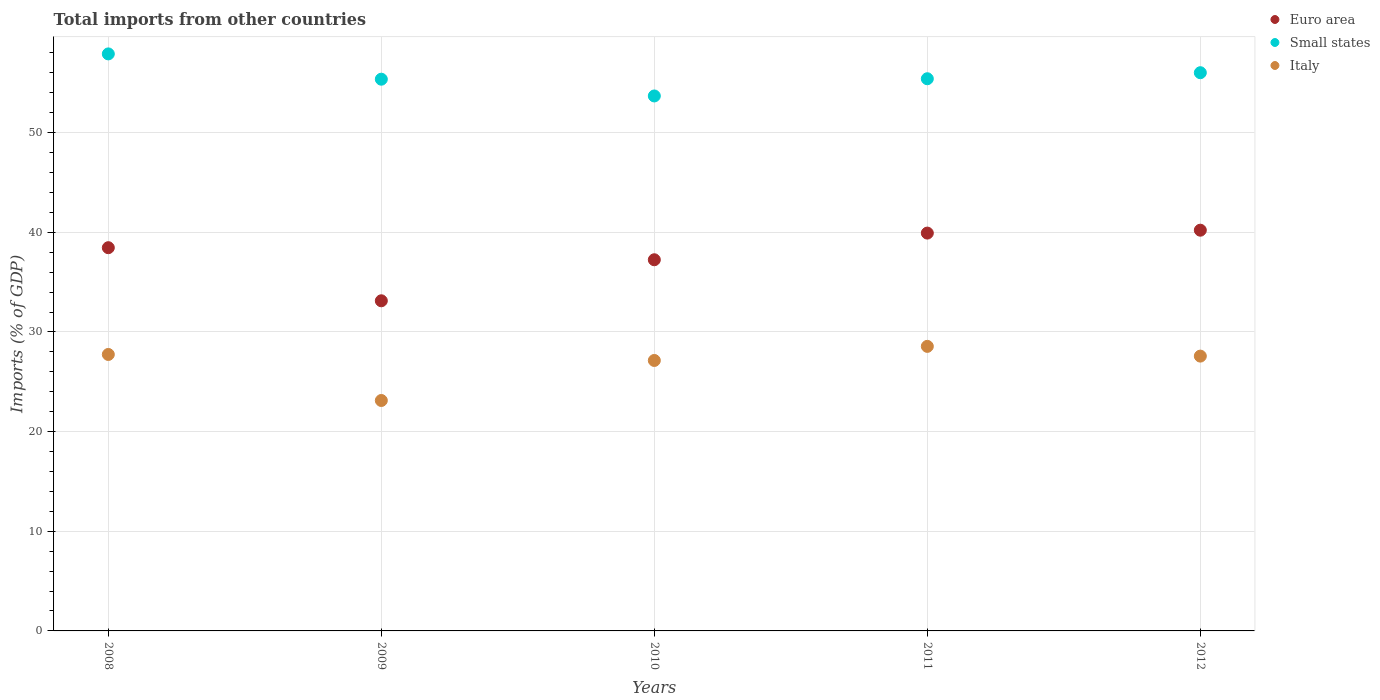Is the number of dotlines equal to the number of legend labels?
Ensure brevity in your answer.  Yes. What is the total imports in Euro area in 2012?
Offer a terse response. 40.21. Across all years, what is the maximum total imports in Italy?
Make the answer very short. 28.55. Across all years, what is the minimum total imports in Euro area?
Ensure brevity in your answer.  33.13. In which year was the total imports in Small states maximum?
Provide a short and direct response. 2008. What is the total total imports in Italy in the graph?
Provide a succinct answer. 134.13. What is the difference between the total imports in Small states in 2009 and that in 2012?
Make the answer very short. -0.65. What is the difference between the total imports in Small states in 2011 and the total imports in Euro area in 2009?
Offer a terse response. 22.28. What is the average total imports in Small states per year?
Your answer should be very brief. 55.67. In the year 2010, what is the difference between the total imports in Small states and total imports in Italy?
Ensure brevity in your answer.  26.54. What is the ratio of the total imports in Small states in 2010 to that in 2012?
Your answer should be compact. 0.96. Is the total imports in Italy in 2008 less than that in 2009?
Ensure brevity in your answer.  No. What is the difference between the highest and the second highest total imports in Small states?
Keep it short and to the point. 1.89. What is the difference between the highest and the lowest total imports in Euro area?
Make the answer very short. 7.08. Is the sum of the total imports in Italy in 2008 and 2012 greater than the maximum total imports in Small states across all years?
Your response must be concise. No. Is it the case that in every year, the sum of the total imports in Italy and total imports in Euro area  is greater than the total imports in Small states?
Provide a succinct answer. Yes. Does the total imports in Small states monotonically increase over the years?
Provide a short and direct response. No. Is the total imports in Euro area strictly less than the total imports in Small states over the years?
Your response must be concise. Yes. What is the difference between two consecutive major ticks on the Y-axis?
Your answer should be very brief. 10. Are the values on the major ticks of Y-axis written in scientific E-notation?
Provide a short and direct response. No. Does the graph contain any zero values?
Offer a very short reply. No. Where does the legend appear in the graph?
Your answer should be very brief. Top right. How many legend labels are there?
Ensure brevity in your answer.  3. How are the legend labels stacked?
Your answer should be compact. Vertical. What is the title of the graph?
Your response must be concise. Total imports from other countries. Does "Gabon" appear as one of the legend labels in the graph?
Provide a short and direct response. No. What is the label or title of the X-axis?
Your answer should be compact. Years. What is the label or title of the Y-axis?
Your answer should be compact. Imports (% of GDP). What is the Imports (% of GDP) of Euro area in 2008?
Make the answer very short. 38.45. What is the Imports (% of GDP) in Small states in 2008?
Provide a short and direct response. 57.9. What is the Imports (% of GDP) of Italy in 2008?
Your response must be concise. 27.74. What is the Imports (% of GDP) of Euro area in 2009?
Provide a short and direct response. 33.13. What is the Imports (% of GDP) in Small states in 2009?
Make the answer very short. 55.36. What is the Imports (% of GDP) of Italy in 2009?
Your answer should be very brief. 23.12. What is the Imports (% of GDP) of Euro area in 2010?
Offer a terse response. 37.24. What is the Imports (% of GDP) in Small states in 2010?
Your response must be concise. 53.68. What is the Imports (% of GDP) of Italy in 2010?
Make the answer very short. 27.14. What is the Imports (% of GDP) of Euro area in 2011?
Give a very brief answer. 39.92. What is the Imports (% of GDP) of Small states in 2011?
Your response must be concise. 55.41. What is the Imports (% of GDP) in Italy in 2011?
Offer a terse response. 28.55. What is the Imports (% of GDP) in Euro area in 2012?
Offer a terse response. 40.21. What is the Imports (% of GDP) in Small states in 2012?
Give a very brief answer. 56.01. What is the Imports (% of GDP) of Italy in 2012?
Ensure brevity in your answer.  27.57. Across all years, what is the maximum Imports (% of GDP) of Euro area?
Your response must be concise. 40.21. Across all years, what is the maximum Imports (% of GDP) in Small states?
Provide a succinct answer. 57.9. Across all years, what is the maximum Imports (% of GDP) of Italy?
Offer a terse response. 28.55. Across all years, what is the minimum Imports (% of GDP) of Euro area?
Your response must be concise. 33.13. Across all years, what is the minimum Imports (% of GDP) of Small states?
Your answer should be very brief. 53.68. Across all years, what is the minimum Imports (% of GDP) of Italy?
Provide a succinct answer. 23.12. What is the total Imports (% of GDP) in Euro area in the graph?
Keep it short and to the point. 188.95. What is the total Imports (% of GDP) of Small states in the graph?
Make the answer very short. 278.35. What is the total Imports (% of GDP) of Italy in the graph?
Offer a very short reply. 134.13. What is the difference between the Imports (% of GDP) in Euro area in 2008 and that in 2009?
Provide a short and direct response. 5.33. What is the difference between the Imports (% of GDP) in Small states in 2008 and that in 2009?
Make the answer very short. 2.54. What is the difference between the Imports (% of GDP) of Italy in 2008 and that in 2009?
Your answer should be very brief. 4.62. What is the difference between the Imports (% of GDP) in Euro area in 2008 and that in 2010?
Provide a succinct answer. 1.21. What is the difference between the Imports (% of GDP) of Small states in 2008 and that in 2010?
Make the answer very short. 4.22. What is the difference between the Imports (% of GDP) in Italy in 2008 and that in 2010?
Ensure brevity in your answer.  0.6. What is the difference between the Imports (% of GDP) of Euro area in 2008 and that in 2011?
Offer a terse response. -1.47. What is the difference between the Imports (% of GDP) of Small states in 2008 and that in 2011?
Give a very brief answer. 2.49. What is the difference between the Imports (% of GDP) in Italy in 2008 and that in 2011?
Your response must be concise. -0.81. What is the difference between the Imports (% of GDP) in Euro area in 2008 and that in 2012?
Give a very brief answer. -1.76. What is the difference between the Imports (% of GDP) of Small states in 2008 and that in 2012?
Ensure brevity in your answer.  1.89. What is the difference between the Imports (% of GDP) in Italy in 2008 and that in 2012?
Provide a succinct answer. 0.17. What is the difference between the Imports (% of GDP) of Euro area in 2009 and that in 2010?
Your response must be concise. -4.12. What is the difference between the Imports (% of GDP) in Small states in 2009 and that in 2010?
Provide a succinct answer. 1.68. What is the difference between the Imports (% of GDP) of Italy in 2009 and that in 2010?
Your answer should be compact. -4.02. What is the difference between the Imports (% of GDP) of Euro area in 2009 and that in 2011?
Your answer should be compact. -6.79. What is the difference between the Imports (% of GDP) of Small states in 2009 and that in 2011?
Keep it short and to the point. -0.05. What is the difference between the Imports (% of GDP) in Italy in 2009 and that in 2011?
Offer a terse response. -5.43. What is the difference between the Imports (% of GDP) of Euro area in 2009 and that in 2012?
Give a very brief answer. -7.08. What is the difference between the Imports (% of GDP) of Small states in 2009 and that in 2012?
Provide a succinct answer. -0.65. What is the difference between the Imports (% of GDP) in Italy in 2009 and that in 2012?
Make the answer very short. -4.45. What is the difference between the Imports (% of GDP) of Euro area in 2010 and that in 2011?
Provide a succinct answer. -2.68. What is the difference between the Imports (% of GDP) of Small states in 2010 and that in 2011?
Provide a short and direct response. -1.73. What is the difference between the Imports (% of GDP) of Italy in 2010 and that in 2011?
Make the answer very short. -1.41. What is the difference between the Imports (% of GDP) of Euro area in 2010 and that in 2012?
Make the answer very short. -2.97. What is the difference between the Imports (% of GDP) of Small states in 2010 and that in 2012?
Provide a succinct answer. -2.33. What is the difference between the Imports (% of GDP) of Italy in 2010 and that in 2012?
Give a very brief answer. -0.44. What is the difference between the Imports (% of GDP) in Euro area in 2011 and that in 2012?
Your response must be concise. -0.29. What is the difference between the Imports (% of GDP) in Small states in 2011 and that in 2012?
Provide a short and direct response. -0.61. What is the difference between the Imports (% of GDP) of Italy in 2011 and that in 2012?
Keep it short and to the point. 0.98. What is the difference between the Imports (% of GDP) in Euro area in 2008 and the Imports (% of GDP) in Small states in 2009?
Your response must be concise. -16.91. What is the difference between the Imports (% of GDP) in Euro area in 2008 and the Imports (% of GDP) in Italy in 2009?
Keep it short and to the point. 15.33. What is the difference between the Imports (% of GDP) in Small states in 2008 and the Imports (% of GDP) in Italy in 2009?
Your answer should be compact. 34.78. What is the difference between the Imports (% of GDP) of Euro area in 2008 and the Imports (% of GDP) of Small states in 2010?
Provide a succinct answer. -15.23. What is the difference between the Imports (% of GDP) of Euro area in 2008 and the Imports (% of GDP) of Italy in 2010?
Your response must be concise. 11.32. What is the difference between the Imports (% of GDP) in Small states in 2008 and the Imports (% of GDP) in Italy in 2010?
Offer a very short reply. 30.76. What is the difference between the Imports (% of GDP) of Euro area in 2008 and the Imports (% of GDP) of Small states in 2011?
Offer a very short reply. -16.95. What is the difference between the Imports (% of GDP) of Euro area in 2008 and the Imports (% of GDP) of Italy in 2011?
Give a very brief answer. 9.9. What is the difference between the Imports (% of GDP) in Small states in 2008 and the Imports (% of GDP) in Italy in 2011?
Give a very brief answer. 29.35. What is the difference between the Imports (% of GDP) in Euro area in 2008 and the Imports (% of GDP) in Small states in 2012?
Provide a succinct answer. -17.56. What is the difference between the Imports (% of GDP) in Euro area in 2008 and the Imports (% of GDP) in Italy in 2012?
Give a very brief answer. 10.88. What is the difference between the Imports (% of GDP) of Small states in 2008 and the Imports (% of GDP) of Italy in 2012?
Give a very brief answer. 30.32. What is the difference between the Imports (% of GDP) in Euro area in 2009 and the Imports (% of GDP) in Small states in 2010?
Provide a short and direct response. -20.55. What is the difference between the Imports (% of GDP) in Euro area in 2009 and the Imports (% of GDP) in Italy in 2010?
Offer a very short reply. 5.99. What is the difference between the Imports (% of GDP) of Small states in 2009 and the Imports (% of GDP) of Italy in 2010?
Provide a short and direct response. 28.22. What is the difference between the Imports (% of GDP) of Euro area in 2009 and the Imports (% of GDP) of Small states in 2011?
Provide a succinct answer. -22.28. What is the difference between the Imports (% of GDP) in Euro area in 2009 and the Imports (% of GDP) in Italy in 2011?
Provide a short and direct response. 4.57. What is the difference between the Imports (% of GDP) of Small states in 2009 and the Imports (% of GDP) of Italy in 2011?
Provide a succinct answer. 26.81. What is the difference between the Imports (% of GDP) in Euro area in 2009 and the Imports (% of GDP) in Small states in 2012?
Provide a short and direct response. -22.89. What is the difference between the Imports (% of GDP) of Euro area in 2009 and the Imports (% of GDP) of Italy in 2012?
Give a very brief answer. 5.55. What is the difference between the Imports (% of GDP) in Small states in 2009 and the Imports (% of GDP) in Italy in 2012?
Make the answer very short. 27.79. What is the difference between the Imports (% of GDP) in Euro area in 2010 and the Imports (% of GDP) in Small states in 2011?
Keep it short and to the point. -18.16. What is the difference between the Imports (% of GDP) in Euro area in 2010 and the Imports (% of GDP) in Italy in 2011?
Provide a succinct answer. 8.69. What is the difference between the Imports (% of GDP) of Small states in 2010 and the Imports (% of GDP) of Italy in 2011?
Your answer should be very brief. 25.13. What is the difference between the Imports (% of GDP) in Euro area in 2010 and the Imports (% of GDP) in Small states in 2012?
Your answer should be very brief. -18.77. What is the difference between the Imports (% of GDP) of Euro area in 2010 and the Imports (% of GDP) of Italy in 2012?
Offer a very short reply. 9.67. What is the difference between the Imports (% of GDP) of Small states in 2010 and the Imports (% of GDP) of Italy in 2012?
Give a very brief answer. 26.1. What is the difference between the Imports (% of GDP) of Euro area in 2011 and the Imports (% of GDP) of Small states in 2012?
Your response must be concise. -16.09. What is the difference between the Imports (% of GDP) of Euro area in 2011 and the Imports (% of GDP) of Italy in 2012?
Provide a short and direct response. 12.34. What is the difference between the Imports (% of GDP) in Small states in 2011 and the Imports (% of GDP) in Italy in 2012?
Offer a very short reply. 27.83. What is the average Imports (% of GDP) of Euro area per year?
Offer a terse response. 37.79. What is the average Imports (% of GDP) of Small states per year?
Your response must be concise. 55.67. What is the average Imports (% of GDP) in Italy per year?
Provide a succinct answer. 26.83. In the year 2008, what is the difference between the Imports (% of GDP) in Euro area and Imports (% of GDP) in Small states?
Make the answer very short. -19.45. In the year 2008, what is the difference between the Imports (% of GDP) of Euro area and Imports (% of GDP) of Italy?
Ensure brevity in your answer.  10.71. In the year 2008, what is the difference between the Imports (% of GDP) in Small states and Imports (% of GDP) in Italy?
Give a very brief answer. 30.16. In the year 2009, what is the difference between the Imports (% of GDP) of Euro area and Imports (% of GDP) of Small states?
Your answer should be very brief. -22.23. In the year 2009, what is the difference between the Imports (% of GDP) in Euro area and Imports (% of GDP) in Italy?
Your answer should be very brief. 10. In the year 2009, what is the difference between the Imports (% of GDP) of Small states and Imports (% of GDP) of Italy?
Provide a succinct answer. 32.24. In the year 2010, what is the difference between the Imports (% of GDP) in Euro area and Imports (% of GDP) in Small states?
Ensure brevity in your answer.  -16.44. In the year 2010, what is the difference between the Imports (% of GDP) of Euro area and Imports (% of GDP) of Italy?
Provide a short and direct response. 10.11. In the year 2010, what is the difference between the Imports (% of GDP) of Small states and Imports (% of GDP) of Italy?
Provide a short and direct response. 26.54. In the year 2011, what is the difference between the Imports (% of GDP) in Euro area and Imports (% of GDP) in Small states?
Offer a very short reply. -15.49. In the year 2011, what is the difference between the Imports (% of GDP) in Euro area and Imports (% of GDP) in Italy?
Offer a very short reply. 11.37. In the year 2011, what is the difference between the Imports (% of GDP) in Small states and Imports (% of GDP) in Italy?
Provide a short and direct response. 26.85. In the year 2012, what is the difference between the Imports (% of GDP) of Euro area and Imports (% of GDP) of Small states?
Make the answer very short. -15.8. In the year 2012, what is the difference between the Imports (% of GDP) in Euro area and Imports (% of GDP) in Italy?
Your response must be concise. 12.63. In the year 2012, what is the difference between the Imports (% of GDP) of Small states and Imports (% of GDP) of Italy?
Offer a very short reply. 28.44. What is the ratio of the Imports (% of GDP) of Euro area in 2008 to that in 2009?
Ensure brevity in your answer.  1.16. What is the ratio of the Imports (% of GDP) of Small states in 2008 to that in 2009?
Provide a short and direct response. 1.05. What is the ratio of the Imports (% of GDP) in Italy in 2008 to that in 2009?
Your answer should be very brief. 1.2. What is the ratio of the Imports (% of GDP) of Euro area in 2008 to that in 2010?
Your answer should be compact. 1.03. What is the ratio of the Imports (% of GDP) in Small states in 2008 to that in 2010?
Your answer should be very brief. 1.08. What is the ratio of the Imports (% of GDP) in Italy in 2008 to that in 2010?
Provide a succinct answer. 1.02. What is the ratio of the Imports (% of GDP) of Euro area in 2008 to that in 2011?
Your answer should be very brief. 0.96. What is the ratio of the Imports (% of GDP) in Small states in 2008 to that in 2011?
Ensure brevity in your answer.  1.04. What is the ratio of the Imports (% of GDP) in Italy in 2008 to that in 2011?
Your answer should be compact. 0.97. What is the ratio of the Imports (% of GDP) in Euro area in 2008 to that in 2012?
Keep it short and to the point. 0.96. What is the ratio of the Imports (% of GDP) of Small states in 2008 to that in 2012?
Offer a very short reply. 1.03. What is the ratio of the Imports (% of GDP) of Euro area in 2009 to that in 2010?
Your answer should be very brief. 0.89. What is the ratio of the Imports (% of GDP) in Small states in 2009 to that in 2010?
Offer a terse response. 1.03. What is the ratio of the Imports (% of GDP) in Italy in 2009 to that in 2010?
Your answer should be compact. 0.85. What is the ratio of the Imports (% of GDP) of Euro area in 2009 to that in 2011?
Offer a terse response. 0.83. What is the ratio of the Imports (% of GDP) in Italy in 2009 to that in 2011?
Give a very brief answer. 0.81. What is the ratio of the Imports (% of GDP) in Euro area in 2009 to that in 2012?
Offer a terse response. 0.82. What is the ratio of the Imports (% of GDP) in Small states in 2009 to that in 2012?
Make the answer very short. 0.99. What is the ratio of the Imports (% of GDP) in Italy in 2009 to that in 2012?
Give a very brief answer. 0.84. What is the ratio of the Imports (% of GDP) of Euro area in 2010 to that in 2011?
Make the answer very short. 0.93. What is the ratio of the Imports (% of GDP) of Small states in 2010 to that in 2011?
Offer a terse response. 0.97. What is the ratio of the Imports (% of GDP) in Italy in 2010 to that in 2011?
Your answer should be very brief. 0.95. What is the ratio of the Imports (% of GDP) in Euro area in 2010 to that in 2012?
Make the answer very short. 0.93. What is the ratio of the Imports (% of GDP) of Small states in 2010 to that in 2012?
Make the answer very short. 0.96. What is the ratio of the Imports (% of GDP) of Italy in 2010 to that in 2012?
Provide a succinct answer. 0.98. What is the ratio of the Imports (% of GDP) in Euro area in 2011 to that in 2012?
Ensure brevity in your answer.  0.99. What is the ratio of the Imports (% of GDP) in Small states in 2011 to that in 2012?
Your response must be concise. 0.99. What is the ratio of the Imports (% of GDP) in Italy in 2011 to that in 2012?
Give a very brief answer. 1.04. What is the difference between the highest and the second highest Imports (% of GDP) in Euro area?
Your answer should be compact. 0.29. What is the difference between the highest and the second highest Imports (% of GDP) in Small states?
Give a very brief answer. 1.89. What is the difference between the highest and the second highest Imports (% of GDP) in Italy?
Provide a succinct answer. 0.81. What is the difference between the highest and the lowest Imports (% of GDP) in Euro area?
Offer a very short reply. 7.08. What is the difference between the highest and the lowest Imports (% of GDP) of Small states?
Your response must be concise. 4.22. What is the difference between the highest and the lowest Imports (% of GDP) of Italy?
Your response must be concise. 5.43. 